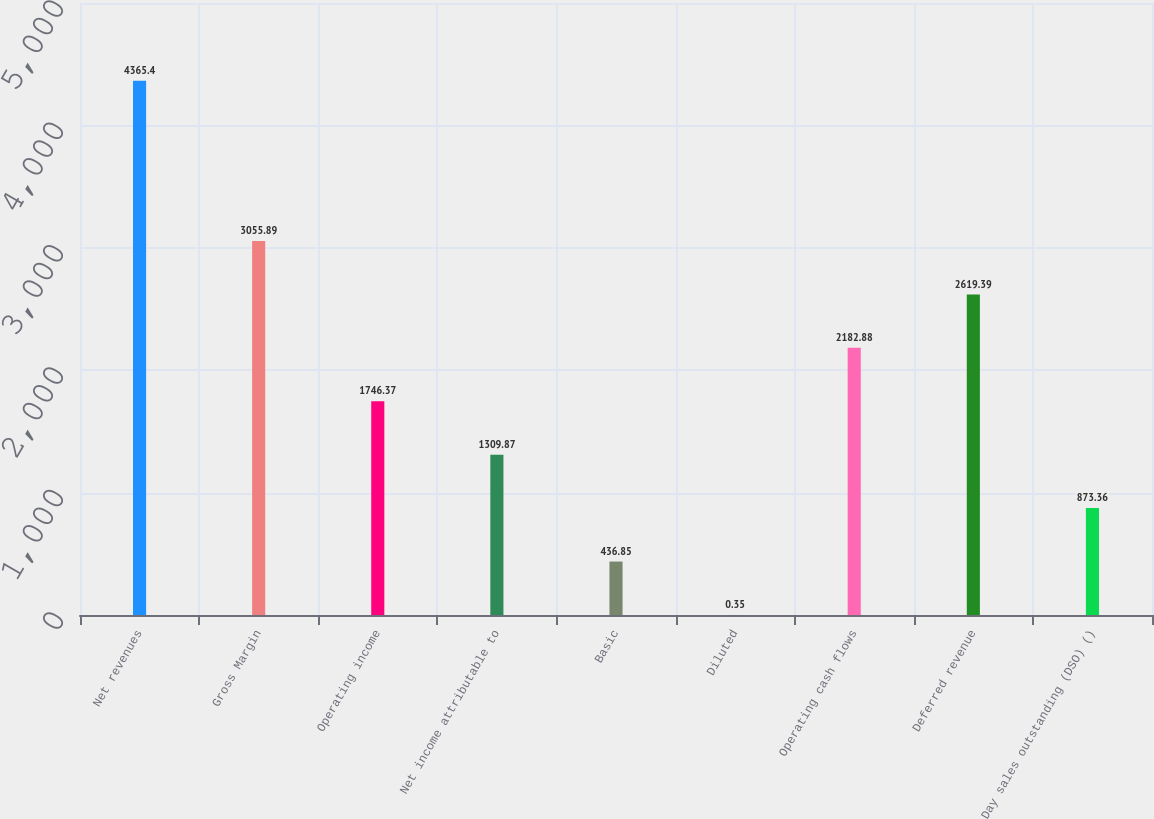Convert chart to OTSL. <chart><loc_0><loc_0><loc_500><loc_500><bar_chart><fcel>Net revenues<fcel>Gross Margin<fcel>Operating income<fcel>Net income attributable to<fcel>Basic<fcel>Diluted<fcel>Operating cash flows<fcel>Deferred revenue<fcel>Day sales outstanding (DSO) ()<nl><fcel>4365.4<fcel>3055.89<fcel>1746.37<fcel>1309.87<fcel>436.85<fcel>0.35<fcel>2182.88<fcel>2619.39<fcel>873.36<nl></chart> 